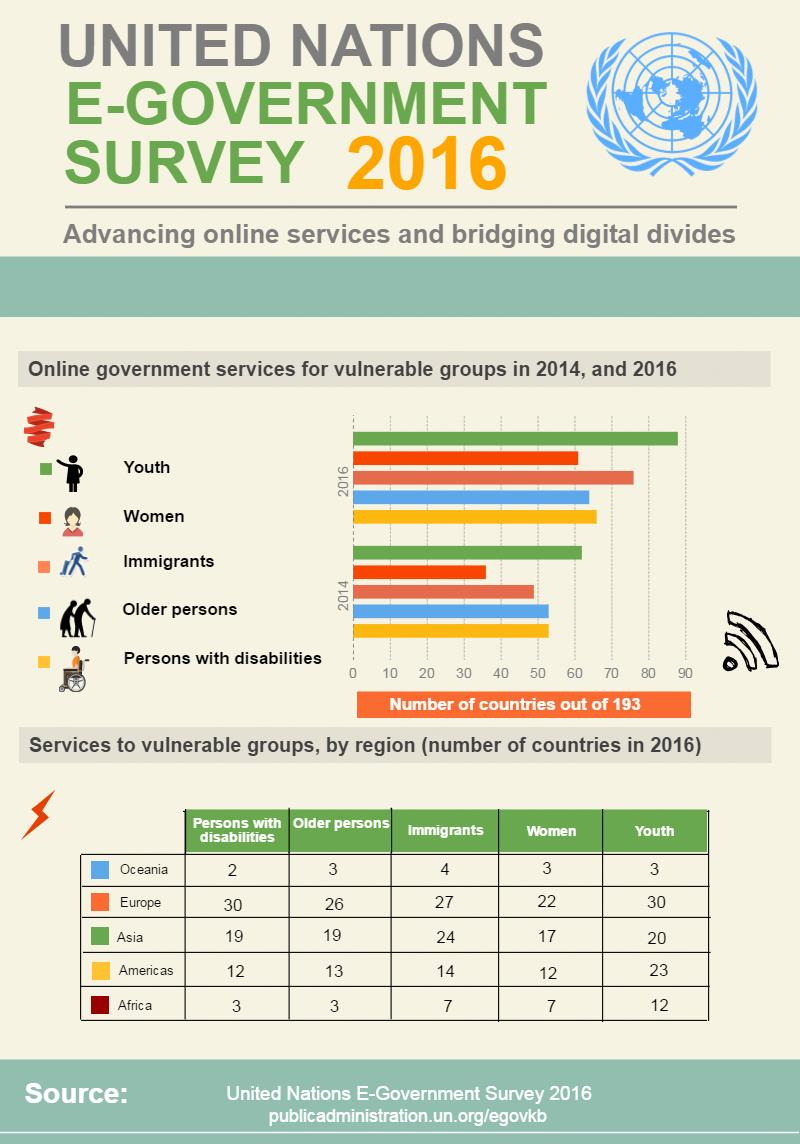Give some essential details in this illustration. The availability and scope of online services for youth in North America and Asia differ significantly. Oceania is the region that provides the lowest total number of services to vulnerable groups. The number of online services provided for persons with disabilities by Europe and Oceania differs. In the Americas, a total of 74 services were provided to vulnerable groups. In 2014, the vulnerable groups of older persons and persons with disabilities had the same level of access to online government services. 